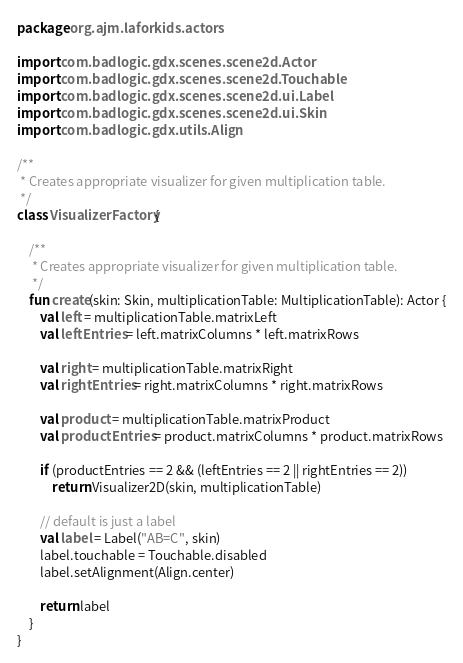<code> <loc_0><loc_0><loc_500><loc_500><_Kotlin_>package org.ajm.laforkids.actors

import com.badlogic.gdx.scenes.scene2d.Actor
import com.badlogic.gdx.scenes.scene2d.Touchable
import com.badlogic.gdx.scenes.scene2d.ui.Label
import com.badlogic.gdx.scenes.scene2d.ui.Skin
import com.badlogic.gdx.utils.Align

/**
 * Creates appropriate visualizer for given multiplication table.
 */
class VisualizerFactory {

    /**
     * Creates appropriate visualizer for given multiplication table.
     */
    fun create(skin: Skin, multiplicationTable: MultiplicationTable): Actor {
        val left = multiplicationTable.matrixLeft
        val leftEntries = left.matrixColumns * left.matrixRows

        val right = multiplicationTable.matrixRight
        val rightEntries = right.matrixColumns * right.matrixRows

        val product = multiplicationTable.matrixProduct
        val productEntries = product.matrixColumns * product.matrixRows

        if (productEntries == 2 && (leftEntries == 2 || rightEntries == 2))
            return Visualizer2D(skin, multiplicationTable)

        // default is just a label
        val label = Label("AB=C", skin)
        label.touchable = Touchable.disabled
        label.setAlignment(Align.center)

        return label
    }
}</code> 